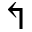Convert formula to latex. <formula><loc_0><loc_0><loc_500><loc_500>\L s h</formula> 